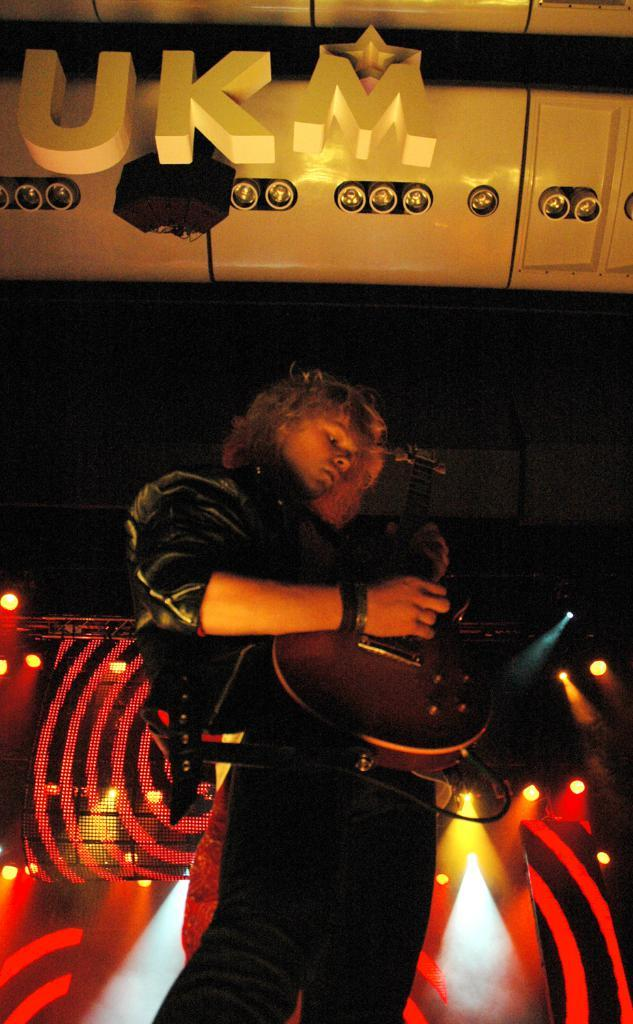What is the person in the image doing? The person is playing a guitar. What can be seen in the background of the image? There are lights in the background of the image. What is written or displayed in the image? There is text visible in the image. Where are the additional lights located in the image? There are additional lights at the top of the image. What is present at the top of the image besides the lights? There is a speaker at the top of the image. How many cakes are being served from the zipper in the image? There is no zipper or cakes present in the image. 